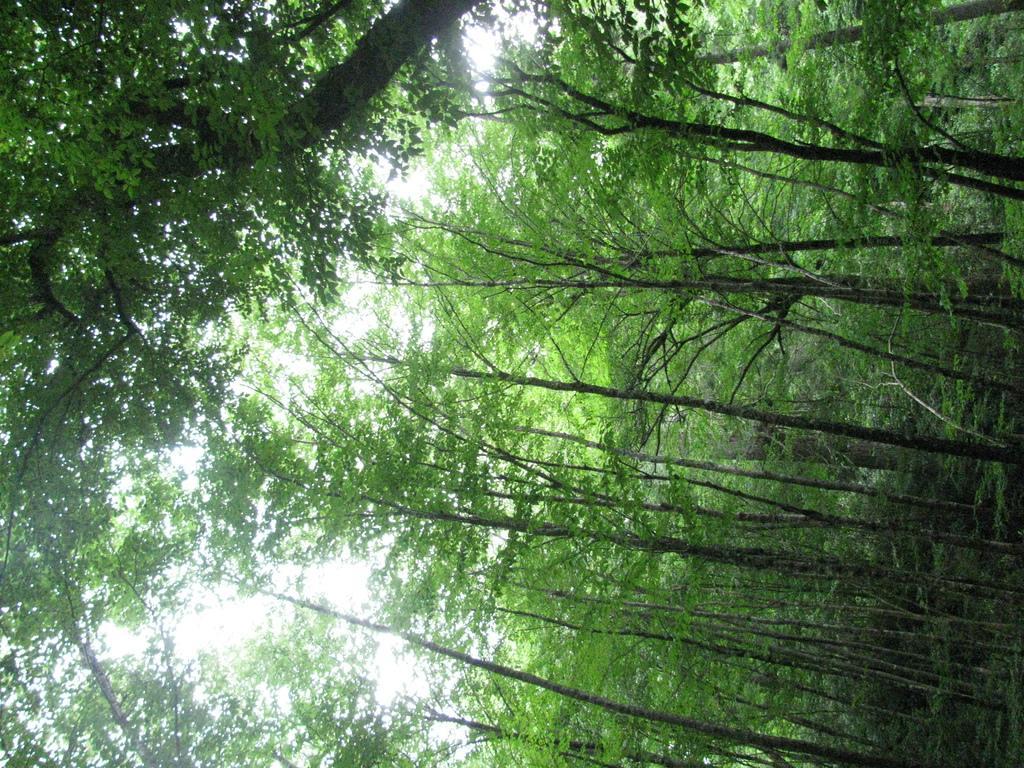How would you summarize this image in a sentence or two? In this picture there are trees and at the background there is sky. 